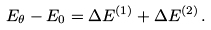<formula> <loc_0><loc_0><loc_500><loc_500>E _ { \theta } - E _ { 0 } = \Delta E ^ { ( 1 ) } + \Delta E ^ { ( 2 ) } \, .</formula> 